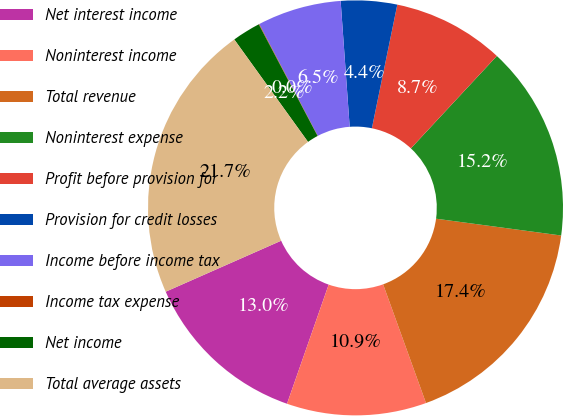Convert chart to OTSL. <chart><loc_0><loc_0><loc_500><loc_500><pie_chart><fcel>Net interest income<fcel>Noninterest income<fcel>Total revenue<fcel>Noninterest expense<fcel>Profit before provision for<fcel>Provision for credit losses<fcel>Income before income tax<fcel>Income tax expense<fcel>Net income<fcel>Total average assets<nl><fcel>13.03%<fcel>10.87%<fcel>17.36%<fcel>15.2%<fcel>8.7%<fcel>4.37%<fcel>6.54%<fcel>0.04%<fcel>2.21%<fcel>21.69%<nl></chart> 